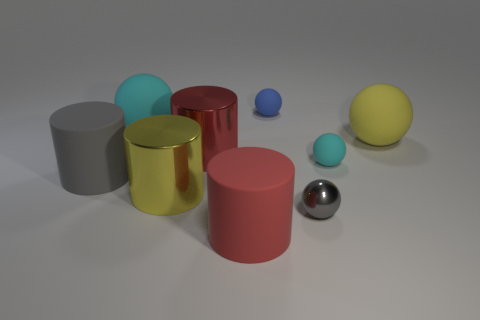What number of things are both right of the red metal thing and in front of the large gray rubber object?
Your answer should be compact. 2. There is a red cylinder behind the yellow metal thing; what material is it?
Ensure brevity in your answer.  Metal. The red cylinder that is made of the same material as the tiny cyan object is what size?
Offer a terse response. Large. Are there any cyan objects right of the big red matte cylinder?
Offer a very short reply. Yes. The other matte object that is the same shape as the gray matte object is what size?
Ensure brevity in your answer.  Large. There is a shiny sphere; does it have the same color as the cylinder in front of the shiny sphere?
Provide a succinct answer. No. Is the number of blue metallic objects less than the number of small blue matte objects?
Keep it short and to the point. Yes. What number of other objects are there of the same color as the shiny ball?
Ensure brevity in your answer.  1. How many large green rubber cylinders are there?
Your answer should be very brief. 0. Are there fewer cyan objects that are on the left side of the large cyan matte sphere than big cyan objects?
Provide a succinct answer. Yes. 